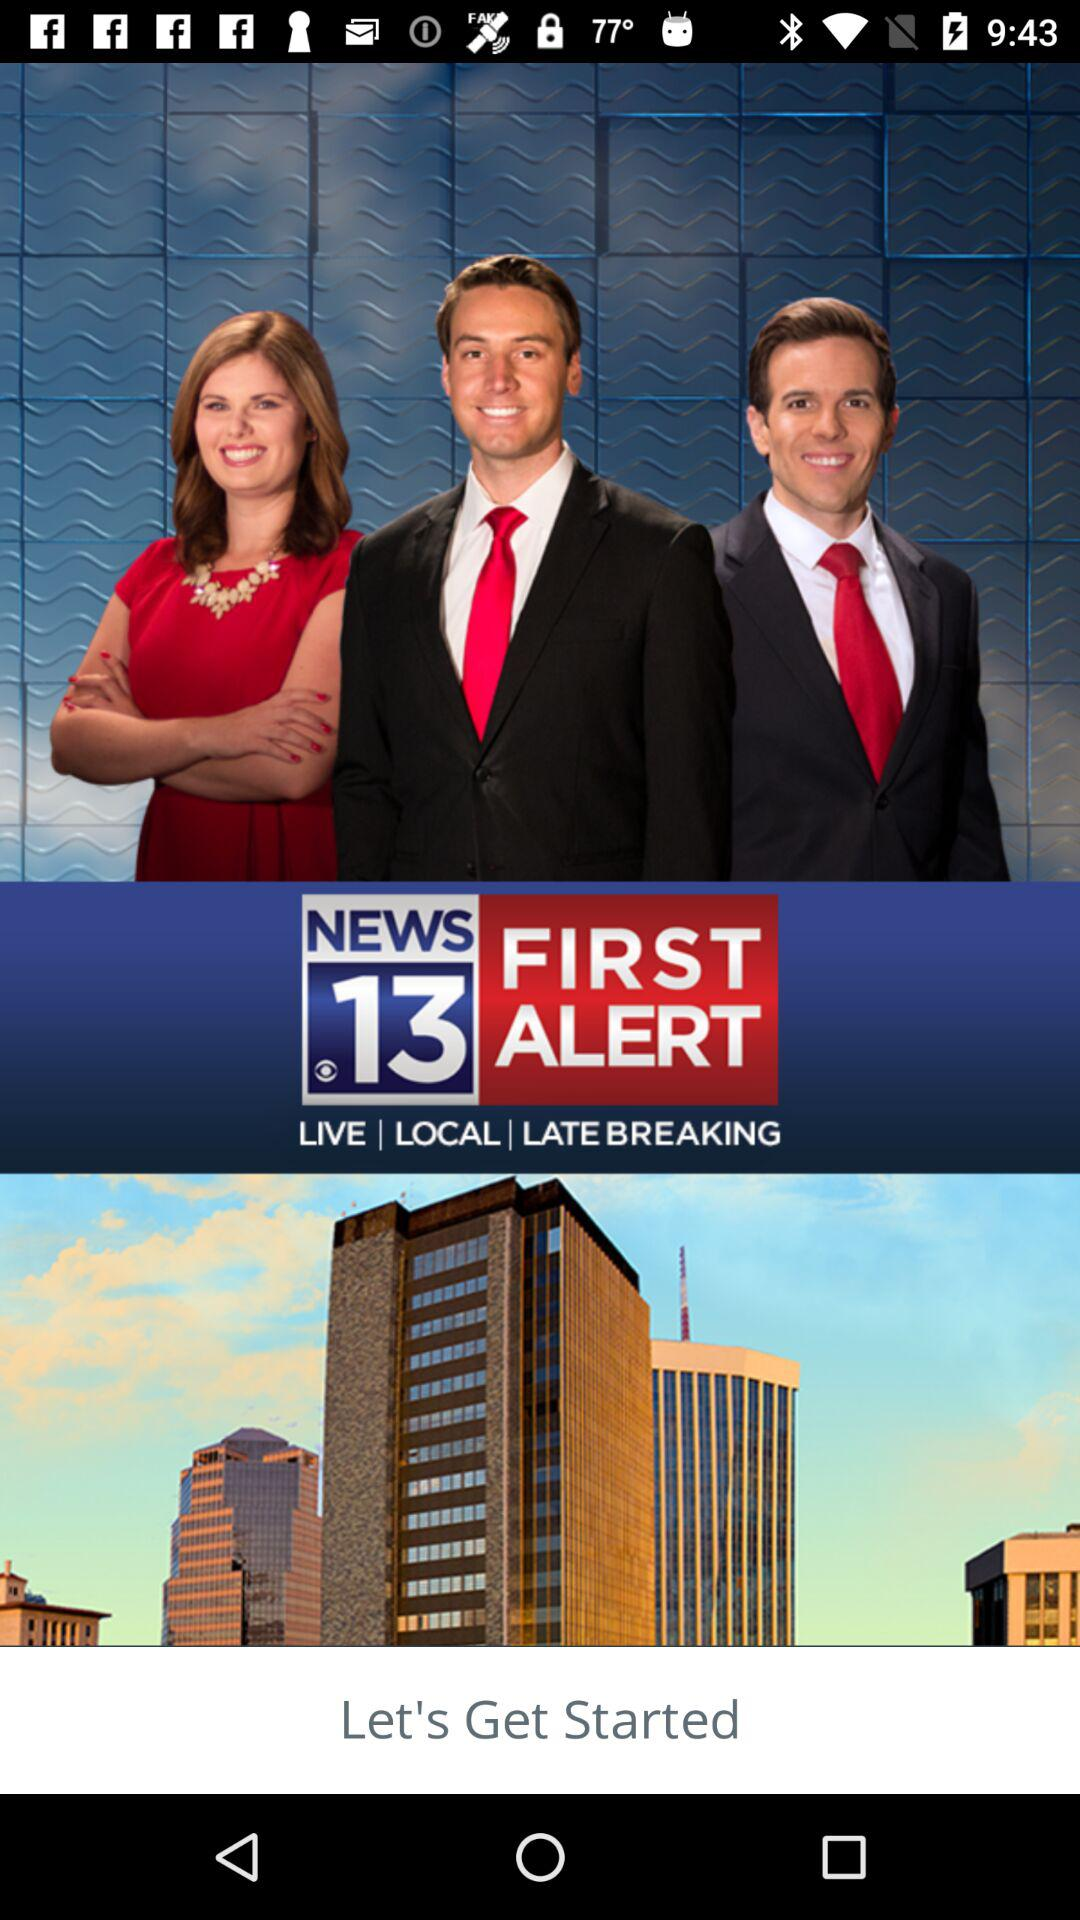What is the application name? The application name is "KOLD 13". 